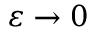<formula> <loc_0><loc_0><loc_500><loc_500>\varepsilon \rightarrow 0</formula> 